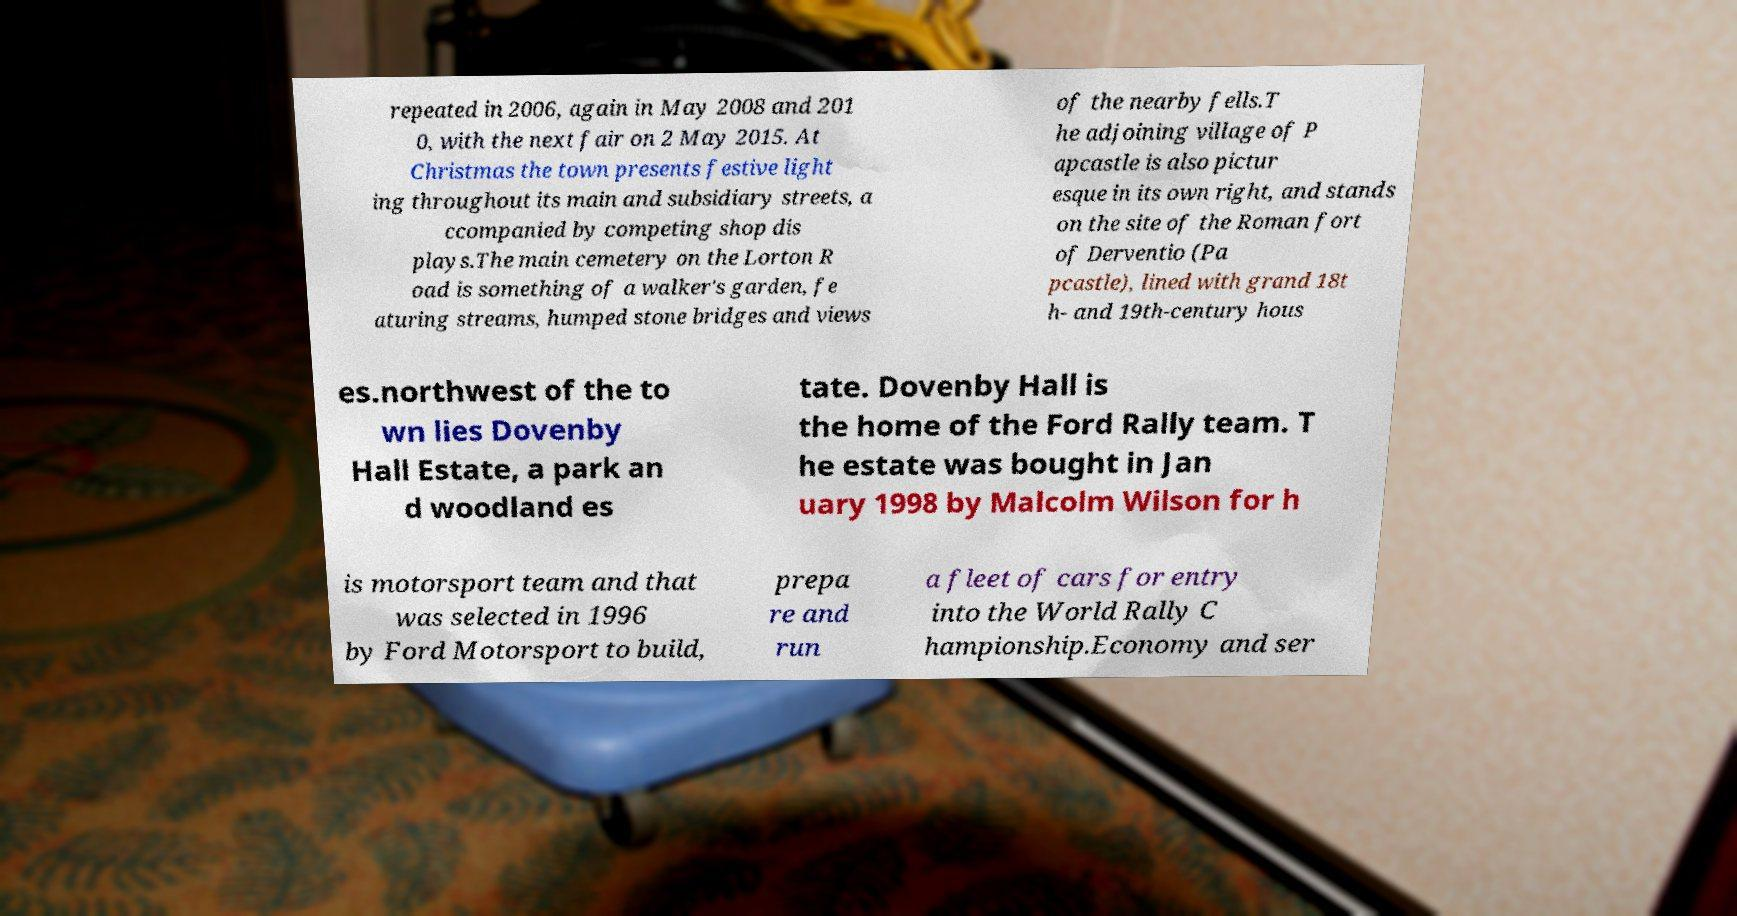Please read and relay the text visible in this image. What does it say? repeated in 2006, again in May 2008 and 201 0, with the next fair on 2 May 2015. At Christmas the town presents festive light ing throughout its main and subsidiary streets, a ccompanied by competing shop dis plays.The main cemetery on the Lorton R oad is something of a walker's garden, fe aturing streams, humped stone bridges and views of the nearby fells.T he adjoining village of P apcastle is also pictur esque in its own right, and stands on the site of the Roman fort of Derventio (Pa pcastle), lined with grand 18t h- and 19th-century hous es.northwest of the to wn lies Dovenby Hall Estate, a park an d woodland es tate. Dovenby Hall is the home of the Ford Rally team. T he estate was bought in Jan uary 1998 by Malcolm Wilson for h is motorsport team and that was selected in 1996 by Ford Motorsport to build, prepa re and run a fleet of cars for entry into the World Rally C hampionship.Economy and ser 